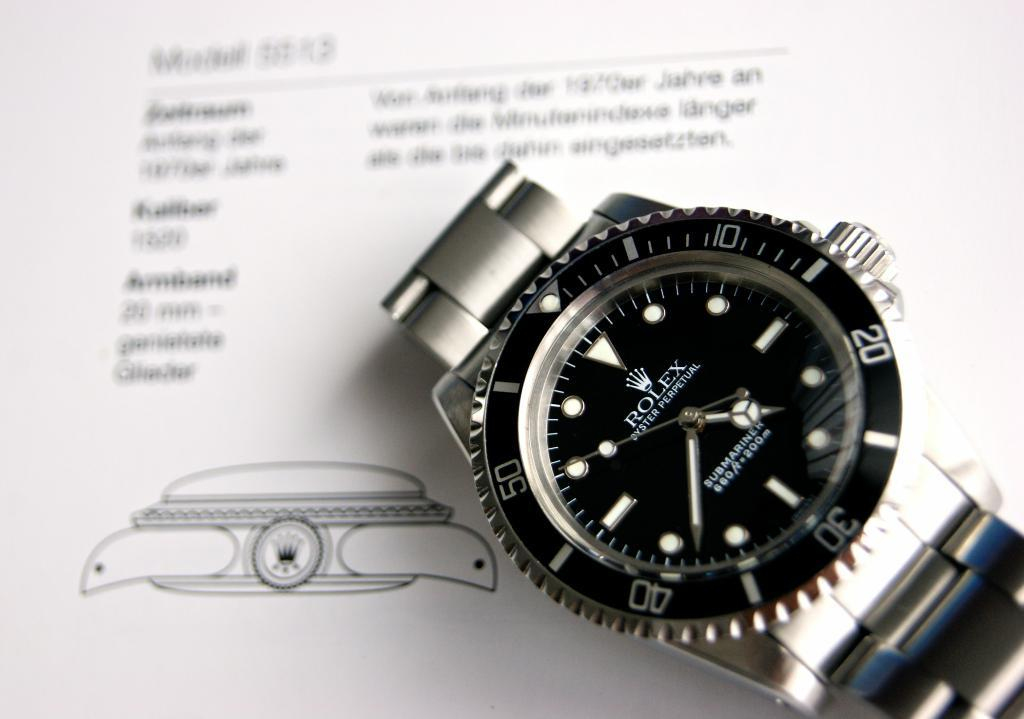<image>
Share a concise interpretation of the image provided. Black and silver wristwatch that says ROLEX on the face. 